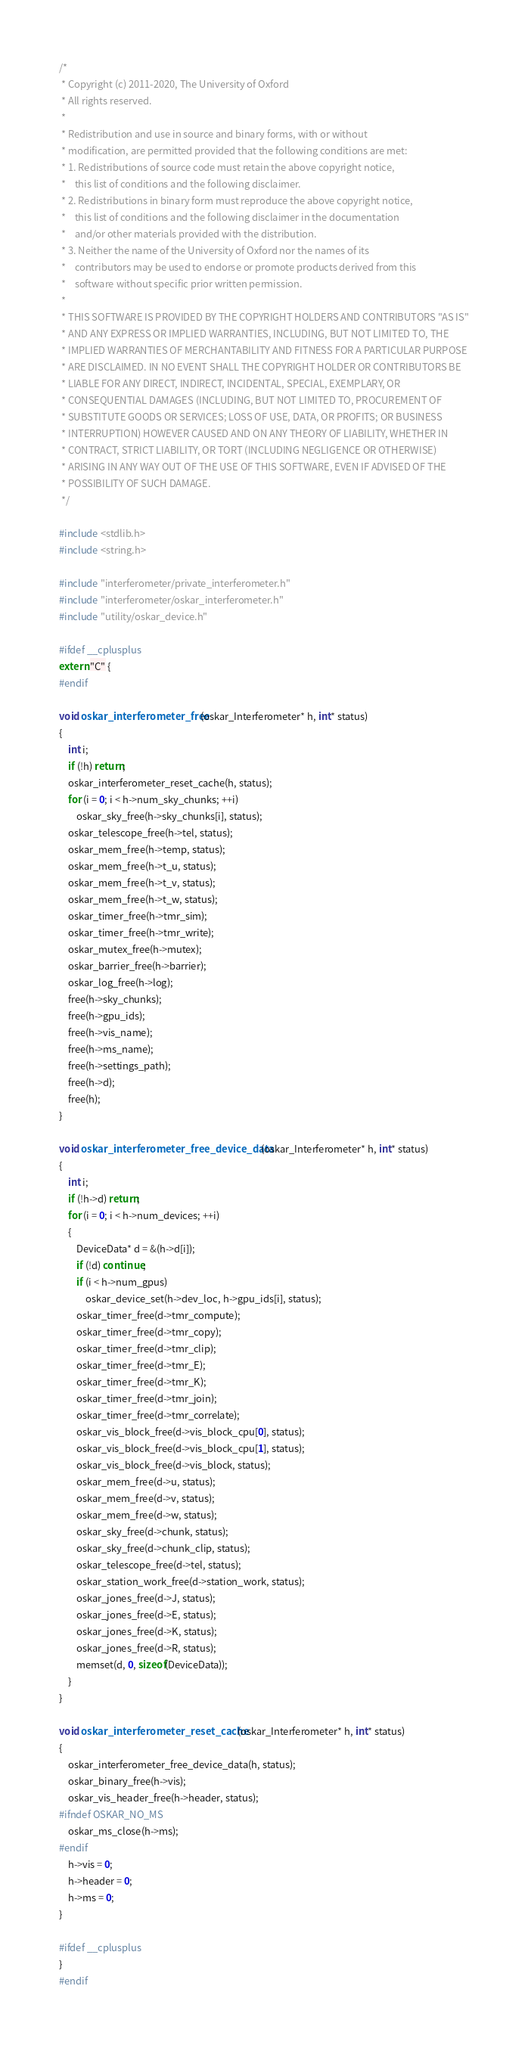Convert code to text. <code><loc_0><loc_0><loc_500><loc_500><_C_>/*
 * Copyright (c) 2011-2020, The University of Oxford
 * All rights reserved.
 *
 * Redistribution and use in source and binary forms, with or without
 * modification, are permitted provided that the following conditions are met:
 * 1. Redistributions of source code must retain the above copyright notice,
 *    this list of conditions and the following disclaimer.
 * 2. Redistributions in binary form must reproduce the above copyright notice,
 *    this list of conditions and the following disclaimer in the documentation
 *    and/or other materials provided with the distribution.
 * 3. Neither the name of the University of Oxford nor the names of its
 *    contributors may be used to endorse or promote products derived from this
 *    software without specific prior written permission.
 *
 * THIS SOFTWARE IS PROVIDED BY THE COPYRIGHT HOLDERS AND CONTRIBUTORS "AS IS"
 * AND ANY EXPRESS OR IMPLIED WARRANTIES, INCLUDING, BUT NOT LIMITED TO, THE
 * IMPLIED WARRANTIES OF MERCHANTABILITY AND FITNESS FOR A PARTICULAR PURPOSE
 * ARE DISCLAIMED. IN NO EVENT SHALL THE COPYRIGHT HOLDER OR CONTRIBUTORS BE
 * LIABLE FOR ANY DIRECT, INDIRECT, INCIDENTAL, SPECIAL, EXEMPLARY, OR
 * CONSEQUENTIAL DAMAGES (INCLUDING, BUT NOT LIMITED TO, PROCUREMENT OF
 * SUBSTITUTE GOODS OR SERVICES; LOSS OF USE, DATA, OR PROFITS; OR BUSINESS
 * INTERRUPTION) HOWEVER CAUSED AND ON ANY THEORY OF LIABILITY, WHETHER IN
 * CONTRACT, STRICT LIABILITY, OR TORT (INCLUDING NEGLIGENCE OR OTHERWISE)
 * ARISING IN ANY WAY OUT OF THE USE OF THIS SOFTWARE, EVEN IF ADVISED OF THE
 * POSSIBILITY OF SUCH DAMAGE.
 */

#include <stdlib.h>
#include <string.h>

#include "interferometer/private_interferometer.h"
#include "interferometer/oskar_interferometer.h"
#include "utility/oskar_device.h"

#ifdef __cplusplus
extern "C" {
#endif

void oskar_interferometer_free(oskar_Interferometer* h, int* status)
{
    int i;
    if (!h) return;
    oskar_interferometer_reset_cache(h, status);
    for (i = 0; i < h->num_sky_chunks; ++i)
        oskar_sky_free(h->sky_chunks[i], status);
    oskar_telescope_free(h->tel, status);
    oskar_mem_free(h->temp, status);
    oskar_mem_free(h->t_u, status);
    oskar_mem_free(h->t_v, status);
    oskar_mem_free(h->t_w, status);
    oskar_timer_free(h->tmr_sim);
    oskar_timer_free(h->tmr_write);
    oskar_mutex_free(h->mutex);
    oskar_barrier_free(h->barrier);
    oskar_log_free(h->log);
    free(h->sky_chunks);
    free(h->gpu_ids);
    free(h->vis_name);
    free(h->ms_name);
    free(h->settings_path);
    free(h->d);
    free(h);
}

void oskar_interferometer_free_device_data(oskar_Interferometer* h, int* status)
{
    int i;
    if (!h->d) return;
    for (i = 0; i < h->num_devices; ++i)
    {
        DeviceData* d = &(h->d[i]);
        if (!d) continue;
        if (i < h->num_gpus)
            oskar_device_set(h->dev_loc, h->gpu_ids[i], status);
        oskar_timer_free(d->tmr_compute);
        oskar_timer_free(d->tmr_copy);
        oskar_timer_free(d->tmr_clip);
        oskar_timer_free(d->tmr_E);
        oskar_timer_free(d->tmr_K);
        oskar_timer_free(d->tmr_join);
        oskar_timer_free(d->tmr_correlate);
        oskar_vis_block_free(d->vis_block_cpu[0], status);
        oskar_vis_block_free(d->vis_block_cpu[1], status);
        oskar_vis_block_free(d->vis_block, status);
        oskar_mem_free(d->u, status);
        oskar_mem_free(d->v, status);
        oskar_mem_free(d->w, status);
        oskar_sky_free(d->chunk, status);
        oskar_sky_free(d->chunk_clip, status);
        oskar_telescope_free(d->tel, status);
        oskar_station_work_free(d->station_work, status);
        oskar_jones_free(d->J, status);
        oskar_jones_free(d->E, status);
        oskar_jones_free(d->K, status);
        oskar_jones_free(d->R, status);
        memset(d, 0, sizeof(DeviceData));
    }
}

void oskar_interferometer_reset_cache(oskar_Interferometer* h, int* status)
{
    oskar_interferometer_free_device_data(h, status);
    oskar_binary_free(h->vis);
    oskar_vis_header_free(h->header, status);
#ifndef OSKAR_NO_MS
    oskar_ms_close(h->ms);
#endif
    h->vis = 0;
    h->header = 0;
    h->ms = 0;
}

#ifdef __cplusplus
}
#endif
</code> 